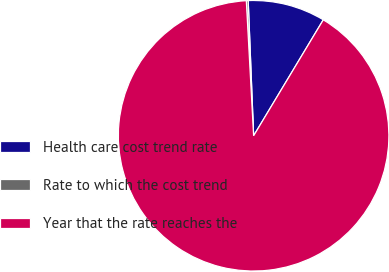<chart> <loc_0><loc_0><loc_500><loc_500><pie_chart><fcel>Health care cost trend rate<fcel>Rate to which the cost trend<fcel>Year that the rate reaches the<nl><fcel>9.25%<fcel>0.22%<fcel>90.52%<nl></chart> 